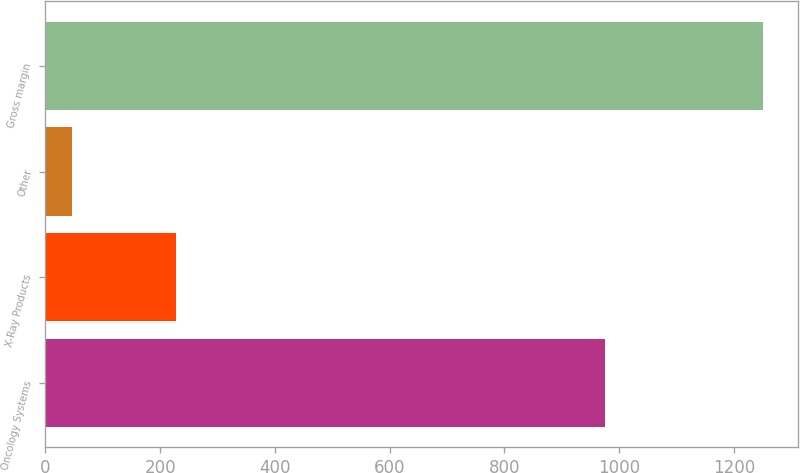Convert chart. <chart><loc_0><loc_0><loc_500><loc_500><bar_chart><fcel>Oncology Systems<fcel>X-Ray Products<fcel>Other<fcel>Gross margin<nl><fcel>976<fcel>227<fcel>47<fcel>1250<nl></chart> 